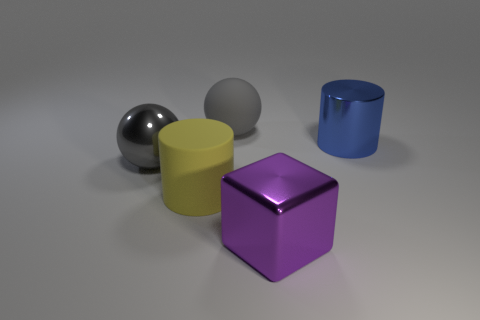Is there anything else that has the same shape as the large purple object?
Make the answer very short. No. There is a blue thing that is the same material as the purple block; what is its shape?
Make the answer very short. Cylinder. Are there the same number of large matte spheres that are to the left of the blue cylinder and matte balls?
Give a very brief answer. Yes. Do the gray object that is behind the gray metallic thing and the big cylinder that is to the left of the big purple block have the same material?
Your response must be concise. Yes. There is a large matte thing to the left of the big gray object to the right of the large metal sphere; what shape is it?
Offer a very short reply. Cylinder. What color is the object that is made of the same material as the big yellow cylinder?
Keep it short and to the point. Gray. Does the big matte ball have the same color as the large metallic ball?
Your answer should be very brief. Yes. There is a purple thing that is the same size as the blue cylinder; what is its shape?
Offer a terse response. Cube. The blue object has what size?
Ensure brevity in your answer.  Large. There is a cylinder left of the large purple metallic object; is it the same size as the gray object to the left of the gray rubber object?
Give a very brief answer. Yes. 